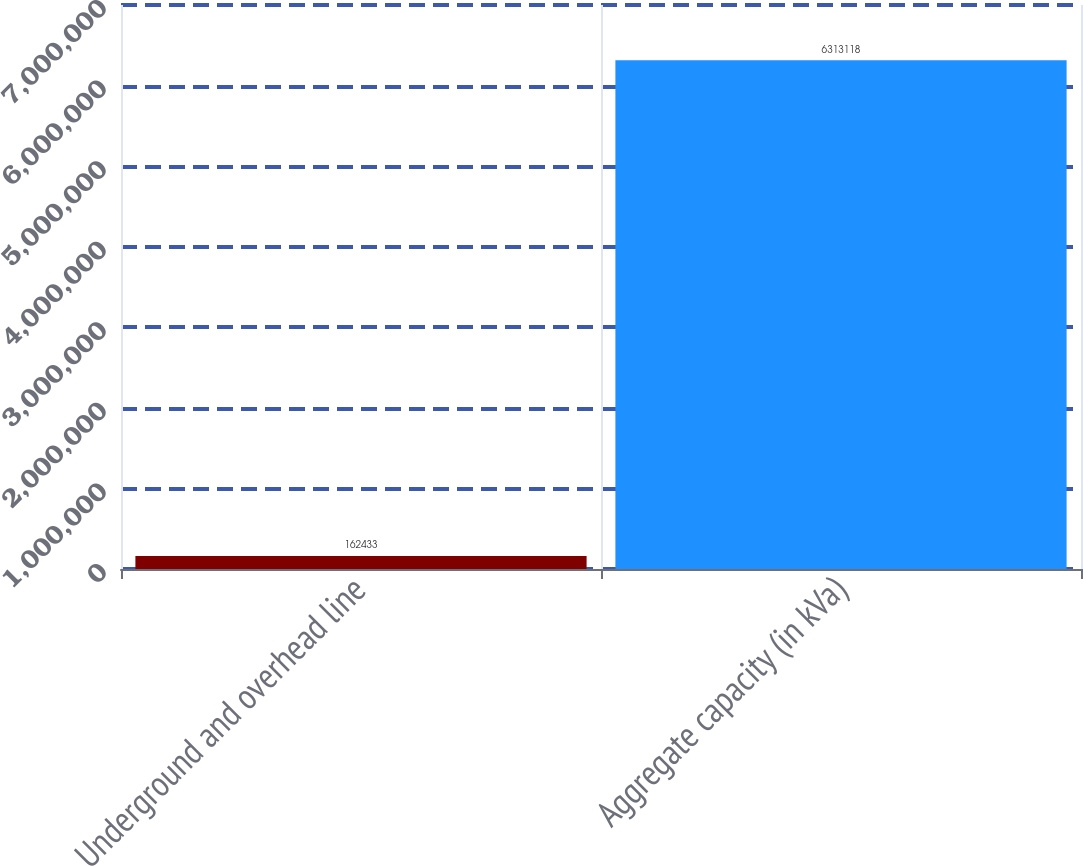Convert chart. <chart><loc_0><loc_0><loc_500><loc_500><bar_chart><fcel>Underground and overhead line<fcel>Aggregate capacity (in kVa)<nl><fcel>162433<fcel>6.31312e+06<nl></chart> 